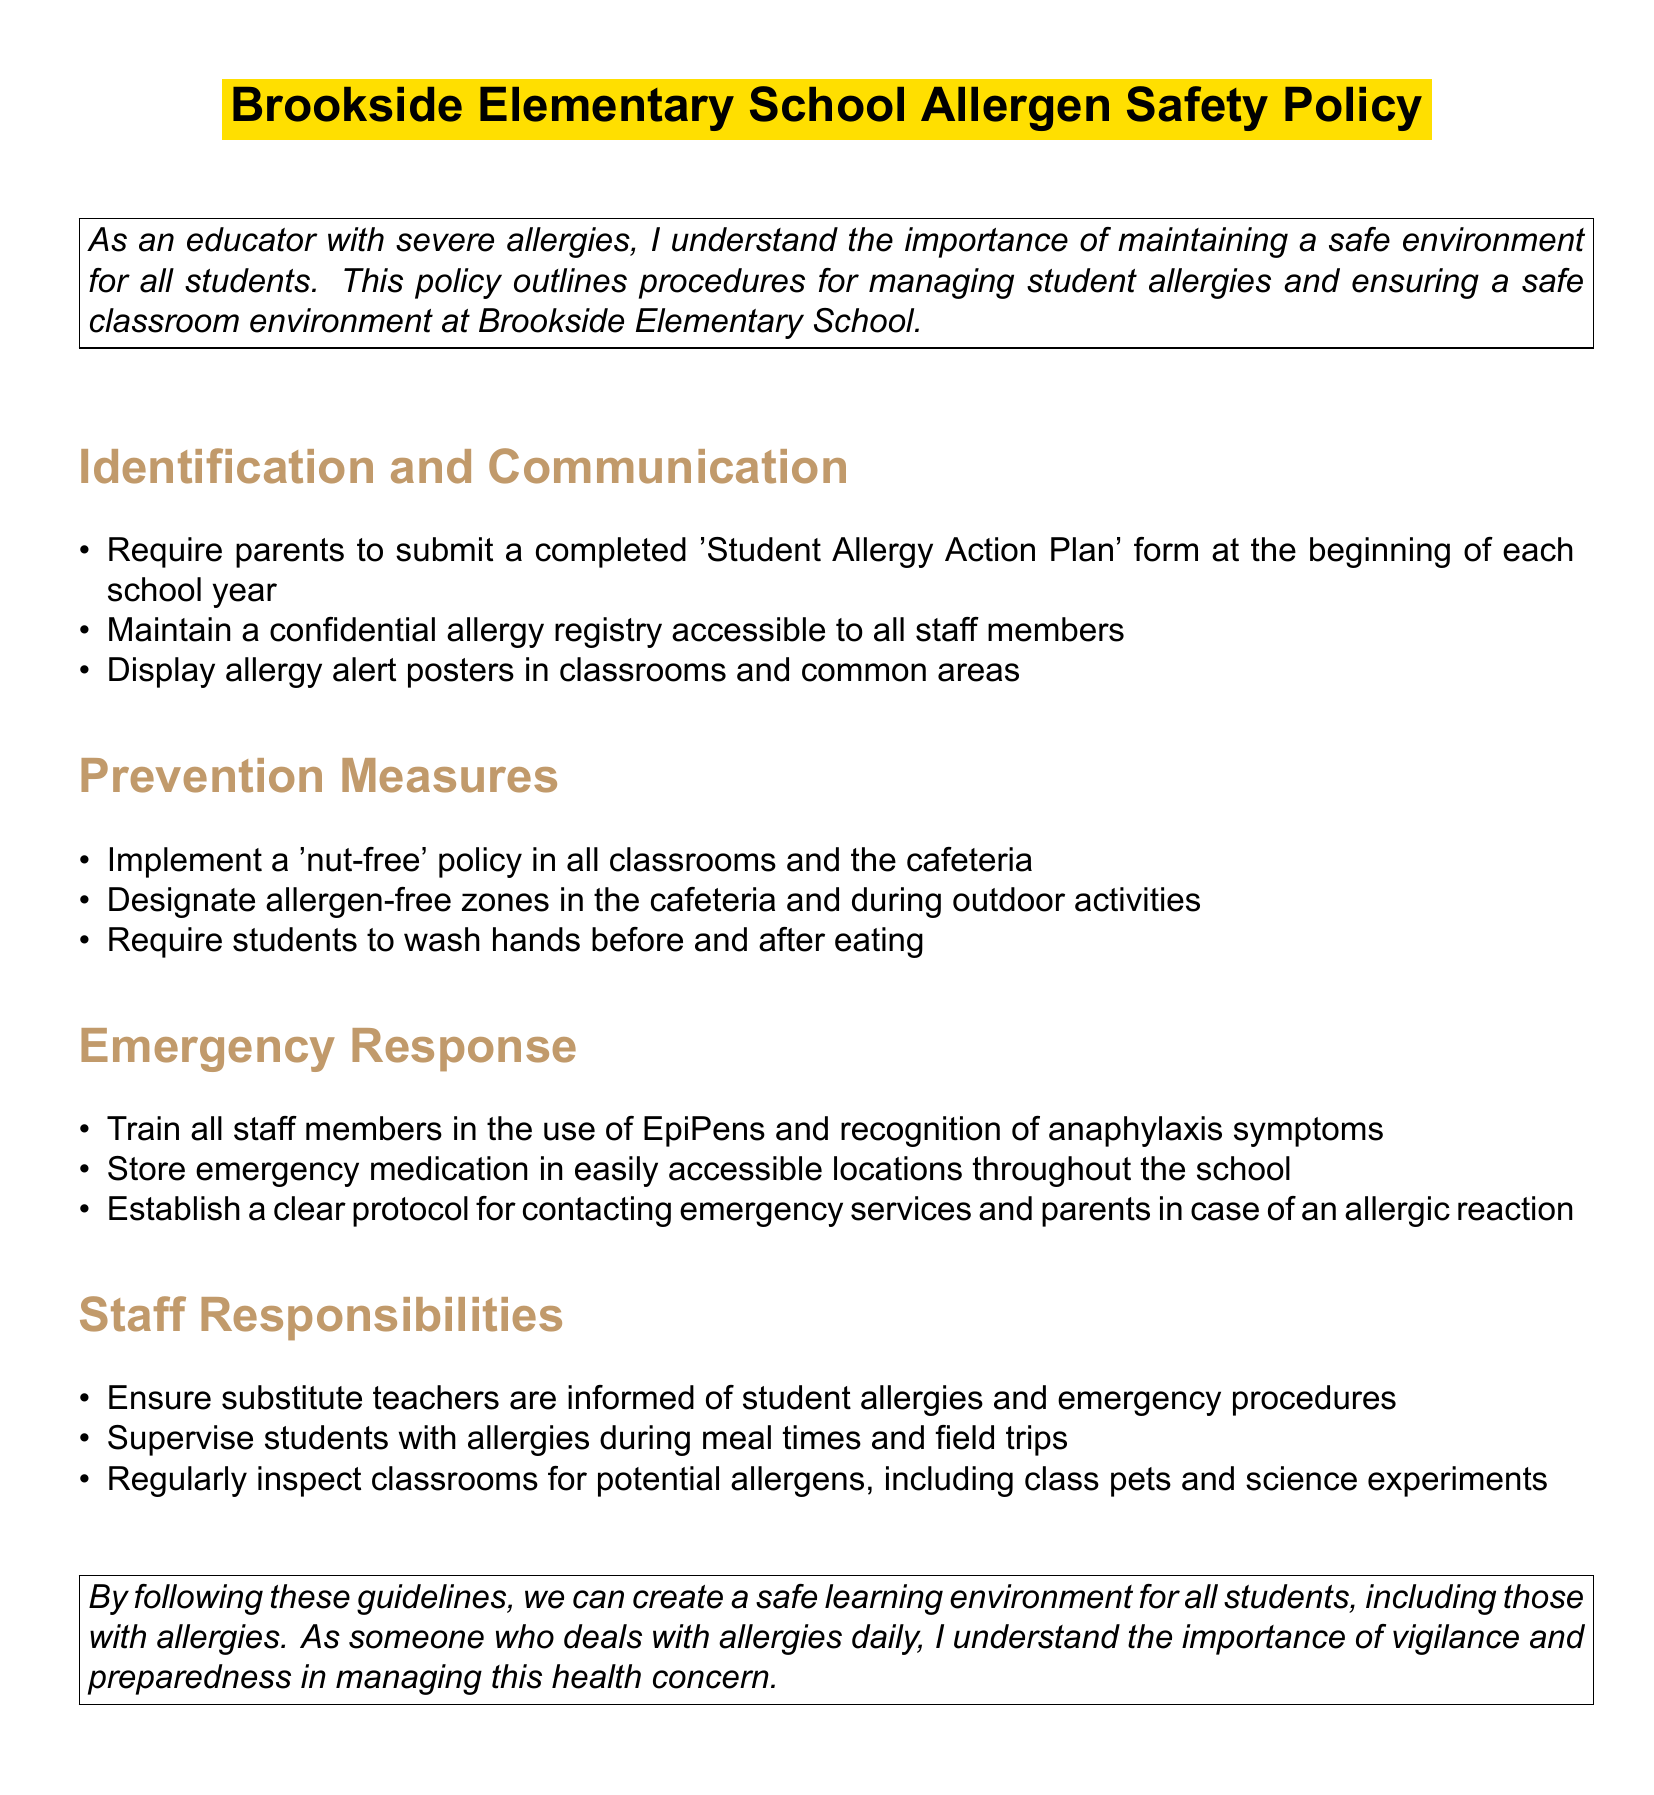What is the title of the policy document? The title is prominently displayed at the top of the document.
Answer: Brookside Elementary School Allergen Safety Policy What must parents submit at the beginning of each school year? This requirement is stated in the Identification and Communication section.
Answer: Student Allergy Action Plan What policy is implemented in all classrooms and the cafeteria? This information is found within the Prevention Measures section.
Answer: Nut-free policy Who should be trained in the use of EpiPens? The requirement is specified under Emergency Response.
Answer: All staff members What should be done before and after eating? This guideline is part of the Prevention Measures outlined.
Answer: Wash hands Which areas are designated as allergen-free zones? This is mentioned in the Prevention Measures section of the document.
Answer: Cafeteria and outdoor activities What specific responsibility do staff have during meal times? This responsibility is detailed under Staff Responsibilities.
Answer: Supervise students with allergies What is stored in easily accessible locations throughout the school? This is stated in the Emergency Response section.
Answer: Emergency medication How should substitute teachers be informed about allergies? This procedure is defined in the Staff Responsibilities section.
Answer: Informed of student allergies and emergency procedures 